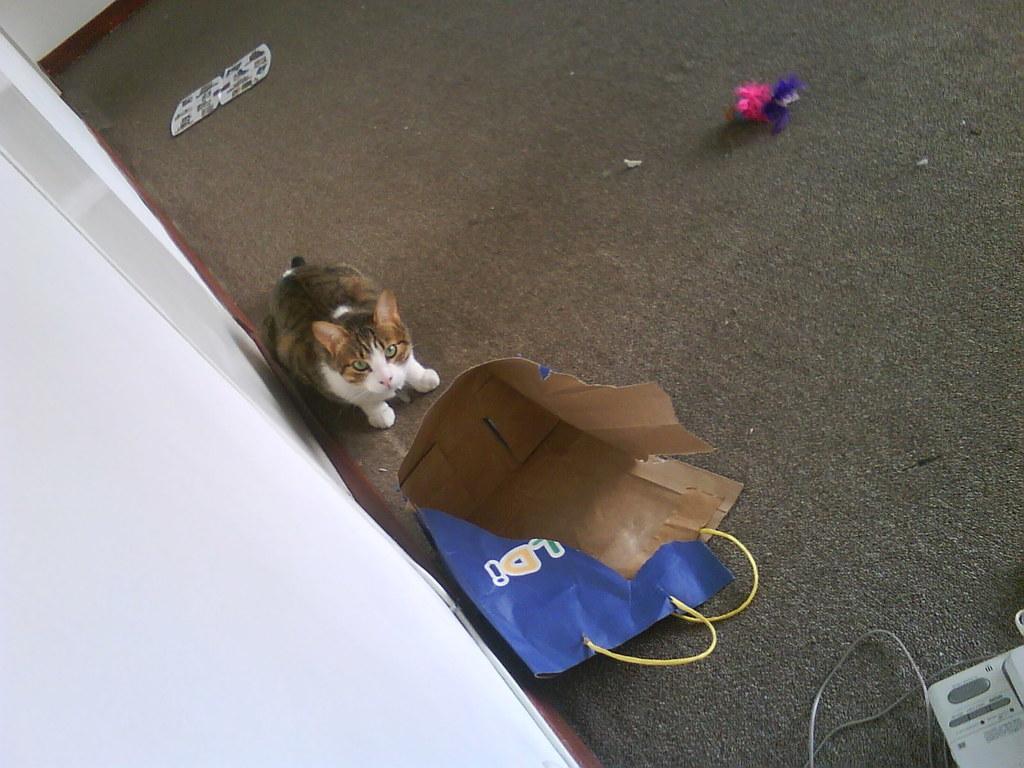Can you describe this image briefly? In this picture there is a cat and a paper bag in the center of the image. 